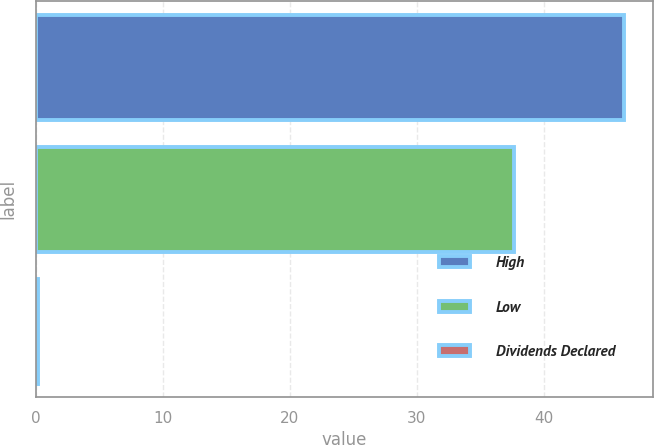<chart> <loc_0><loc_0><loc_500><loc_500><bar_chart><fcel>High<fcel>Low<fcel>Dividends Declared<nl><fcel>46.31<fcel>37.63<fcel>0.21<nl></chart> 